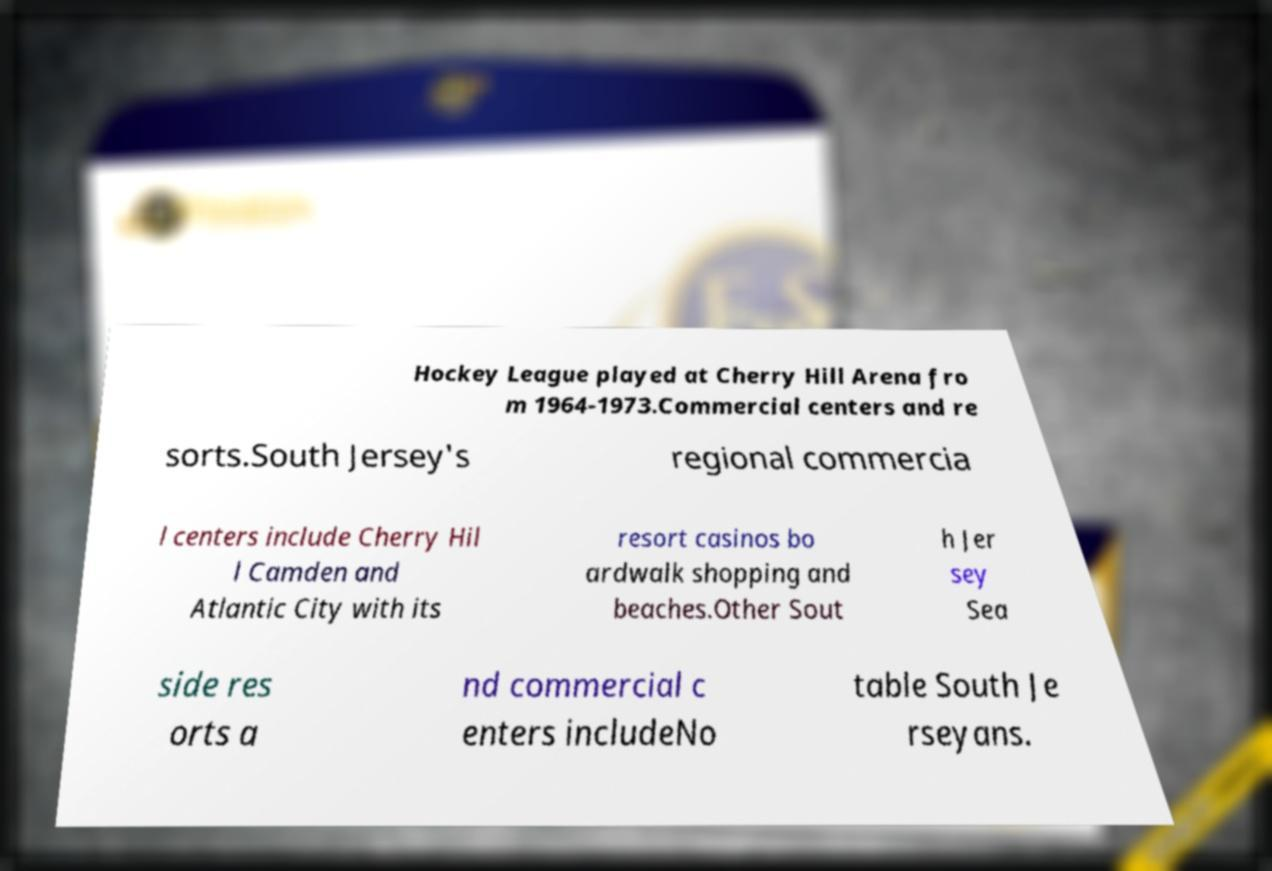Can you accurately transcribe the text from the provided image for me? Hockey League played at Cherry Hill Arena fro m 1964-1973.Commercial centers and re sorts.South Jersey's regional commercia l centers include Cherry Hil l Camden and Atlantic City with its resort casinos bo ardwalk shopping and beaches.Other Sout h Jer sey Sea side res orts a nd commercial c enters includeNo table South Je rseyans. 